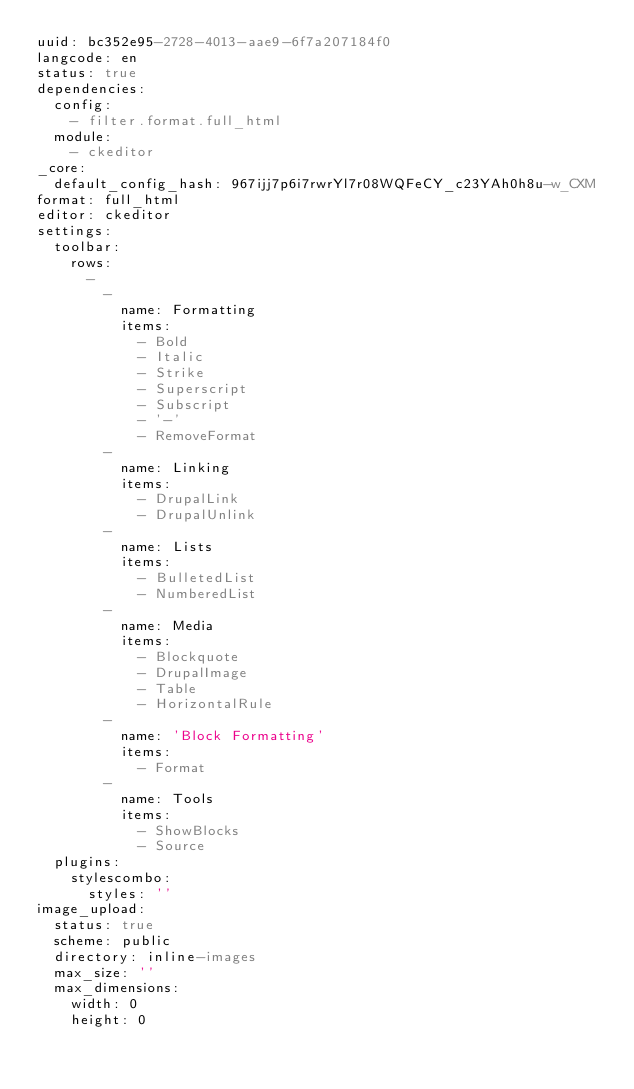Convert code to text. <code><loc_0><loc_0><loc_500><loc_500><_YAML_>uuid: bc352e95-2728-4013-aae9-6f7a207184f0
langcode: en
status: true
dependencies:
  config:
    - filter.format.full_html
  module:
    - ckeditor
_core:
  default_config_hash: 967ijj7p6i7rwrYl7r08WQFeCY_c23YAh0h8u-w_CXM
format: full_html
editor: ckeditor
settings:
  toolbar:
    rows:
      -
        -
          name: Formatting
          items:
            - Bold
            - Italic
            - Strike
            - Superscript
            - Subscript
            - '-'
            - RemoveFormat
        -
          name: Linking
          items:
            - DrupalLink
            - DrupalUnlink
        -
          name: Lists
          items:
            - BulletedList
            - NumberedList
        -
          name: Media
          items:
            - Blockquote
            - DrupalImage
            - Table
            - HorizontalRule
        -
          name: 'Block Formatting'
          items:
            - Format
        -
          name: Tools
          items:
            - ShowBlocks
            - Source
  plugins:
    stylescombo:
      styles: ''
image_upload:
  status: true
  scheme: public
  directory: inline-images
  max_size: ''
  max_dimensions:
    width: 0
    height: 0
</code> 